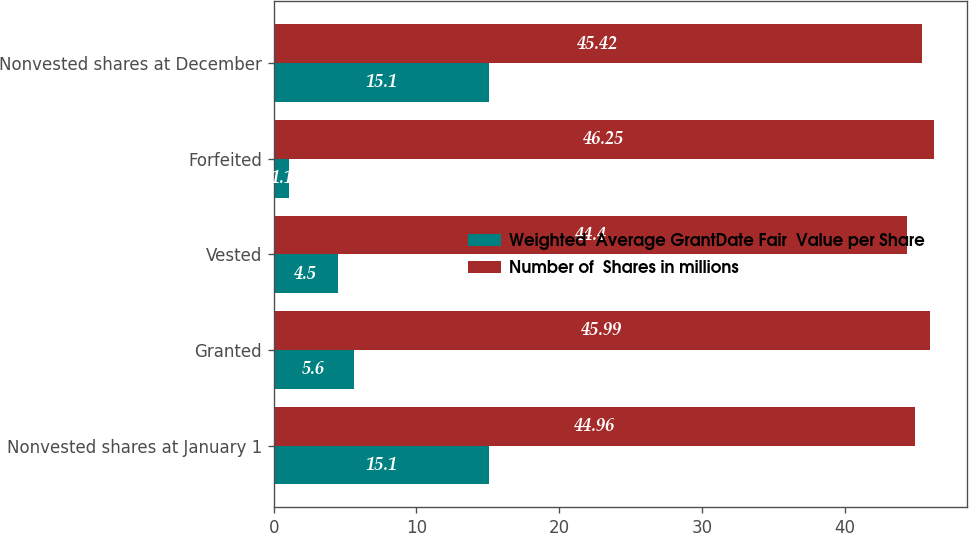Convert chart to OTSL. <chart><loc_0><loc_0><loc_500><loc_500><stacked_bar_chart><ecel><fcel>Nonvested shares at January 1<fcel>Granted<fcel>Vested<fcel>Forfeited<fcel>Nonvested shares at December<nl><fcel>Weighted  Average GrantDate Fair  Value per Share<fcel>15.1<fcel>5.6<fcel>4.5<fcel>1.1<fcel>15.1<nl><fcel>Number of  Shares in millions<fcel>44.96<fcel>45.99<fcel>44.4<fcel>46.25<fcel>45.42<nl></chart> 